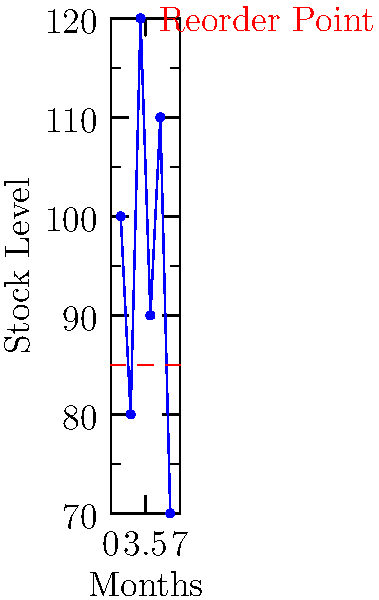Based on the chart showing monthly stock levels for a key component in your manufacturing process, with a reorder point of 85 units, in how many months should you have placed an order to replenish inventory? To answer this question, we need to analyze the stock levels for each month and compare them to the reorder point:

1. Month 1: Stock level = 100 > 85 (Reorder point)
2. Month 2: Stock level = 80 < 85 (Reorder point) - Should order
3. Month 3: Stock level = 120 > 85 (Reorder point)
4. Month 4: Stock level = 90 > 85 (Reorder point)
5. Month 5: Stock level = 110 > 85 (Reorder point)
6. Month 6: Stock level = 70 < 85 (Reorder point) - Should order

We should place an order whenever the stock level falls below the reorder point of 85 units. This occurs in two months: Month 2 and Month 6.

Therefore, you should have placed an order to replenish inventory in 2 months.
Answer: 2 months 